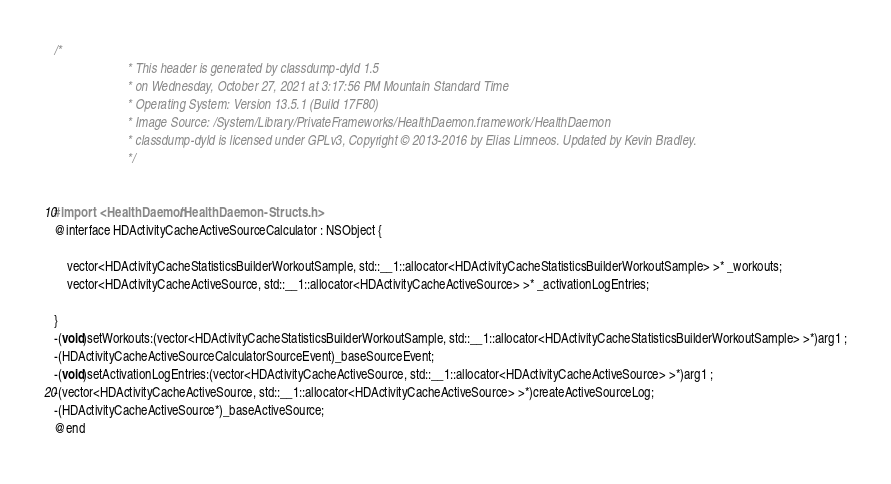<code> <loc_0><loc_0><loc_500><loc_500><_C_>/*
                       * This header is generated by classdump-dyld 1.5
                       * on Wednesday, October 27, 2021 at 3:17:56 PM Mountain Standard Time
                       * Operating System: Version 13.5.1 (Build 17F80)
                       * Image Source: /System/Library/PrivateFrameworks/HealthDaemon.framework/HealthDaemon
                       * classdump-dyld is licensed under GPLv3, Copyright © 2013-2016 by Elias Limneos. Updated by Kevin Bradley.
                       */


#import <HealthDaemon/HealthDaemon-Structs.h>
@interface HDActivityCacheActiveSourceCalculator : NSObject {

	vector<HDActivityCacheStatisticsBuilderWorkoutSample, std::__1::allocator<HDActivityCacheStatisticsBuilderWorkoutSample> >* _workouts;
	vector<HDActivityCacheActiveSource, std::__1::allocator<HDActivityCacheActiveSource> >* _activationLogEntries;

}
-(void)setWorkouts:(vector<HDActivityCacheStatisticsBuilderWorkoutSample, std::__1::allocator<HDActivityCacheStatisticsBuilderWorkoutSample> >*)arg1 ;
-(HDActivityCacheActiveSourceCalculatorSourceEvent)_baseSourceEvent;
-(void)setActivationLogEntries:(vector<HDActivityCacheActiveSource, std::__1::allocator<HDActivityCacheActiveSource> >*)arg1 ;
-(vector<HDActivityCacheActiveSource, std::__1::allocator<HDActivityCacheActiveSource> >*)createActiveSourceLog;
-(HDActivityCacheActiveSource*)_baseActiveSource;
@end

</code> 